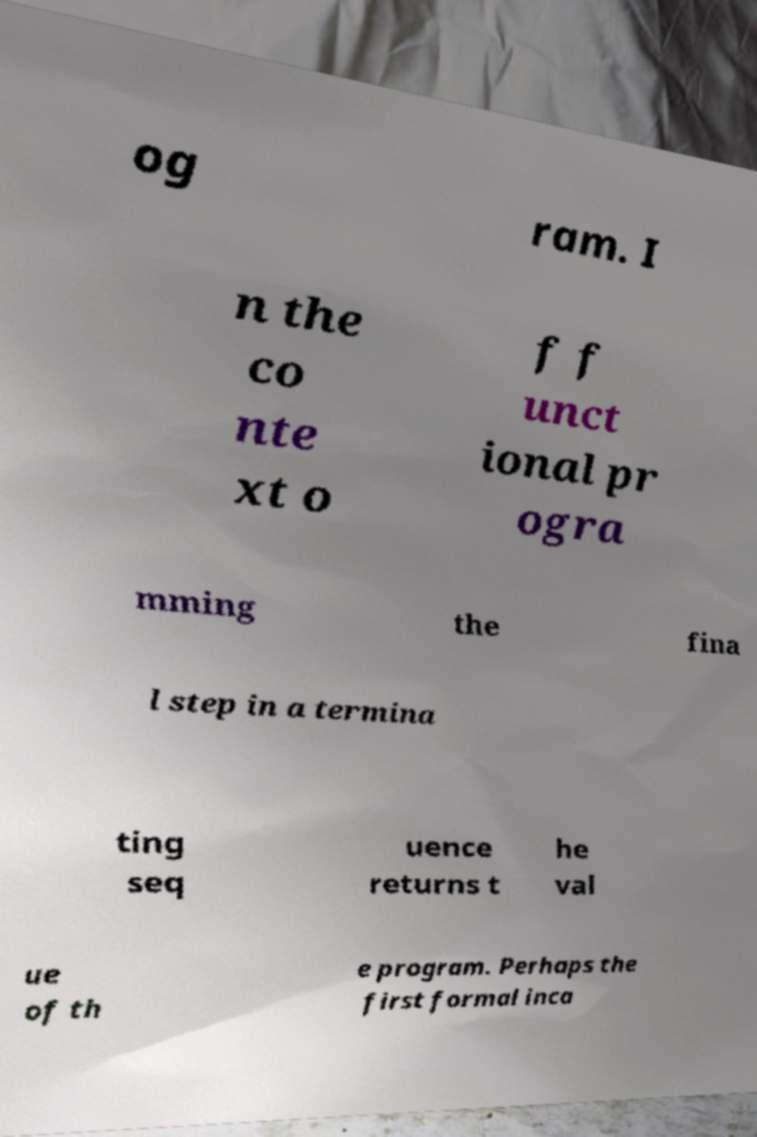Please identify and transcribe the text found in this image. og ram. I n the co nte xt o f f unct ional pr ogra mming the fina l step in a termina ting seq uence returns t he val ue of th e program. Perhaps the first formal inca 